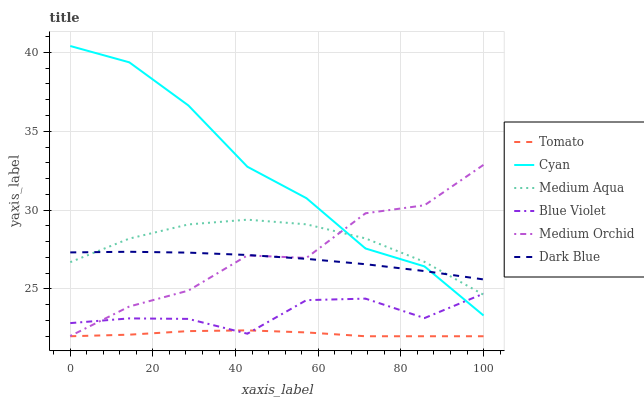Does Medium Orchid have the minimum area under the curve?
Answer yes or no. No. Does Medium Orchid have the maximum area under the curve?
Answer yes or no. No. Is Medium Orchid the smoothest?
Answer yes or no. No. Is Dark Blue the roughest?
Answer yes or no. No. Does Medium Orchid have the lowest value?
Answer yes or no. No. Does Medium Orchid have the highest value?
Answer yes or no. No. Is Tomato less than Medium Orchid?
Answer yes or no. Yes. Is Dark Blue greater than Blue Violet?
Answer yes or no. Yes. Does Tomato intersect Medium Orchid?
Answer yes or no. No. 